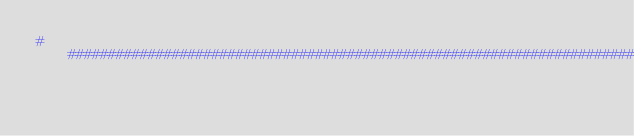<code> <loc_0><loc_0><loc_500><loc_500><_Python_>#################################################################################</code> 